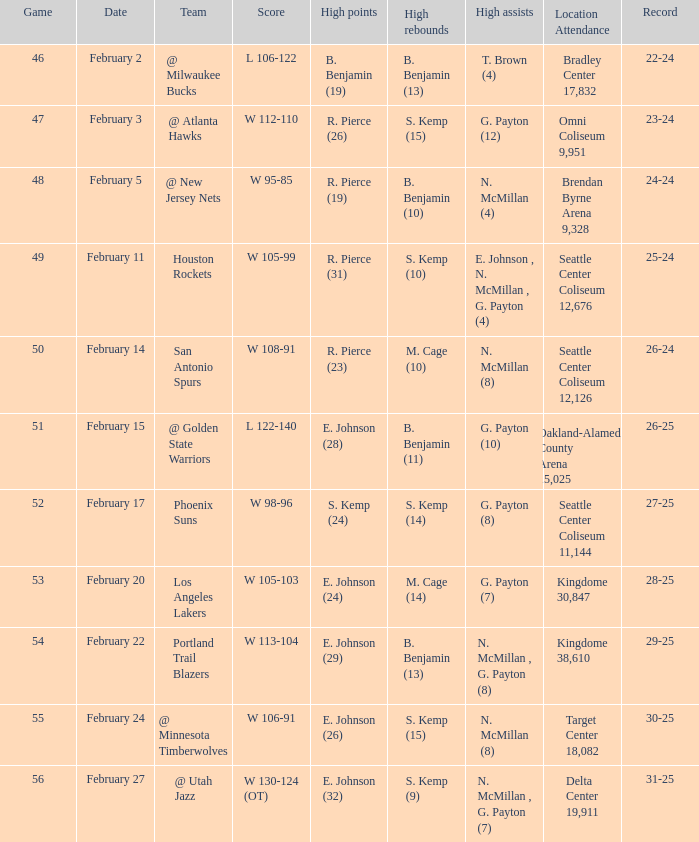What dated was the game played at the location delta center 19,911? February 27. 